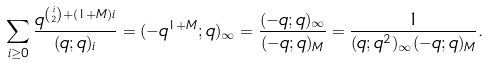Convert formula to latex. <formula><loc_0><loc_0><loc_500><loc_500>\sum _ { i \geq 0 } \frac { q ^ { \binom { i } { 2 } + ( 1 + M ) i } } { ( q ; q ) _ { i } } = ( - q ^ { 1 + M } ; q ) _ { \infty } = \frac { ( - q ; q ) _ { \infty } } { ( - q ; q ) _ { M } } = \frac { 1 } { ( q ; q ^ { 2 } ) _ { \infty } ( - q ; q ) _ { M } } .</formula> 